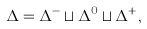Convert formula to latex. <formula><loc_0><loc_0><loc_500><loc_500>\Delta = \Delta ^ { - } \sqcup \Delta ^ { 0 } \sqcup \Delta ^ { + } ,</formula> 